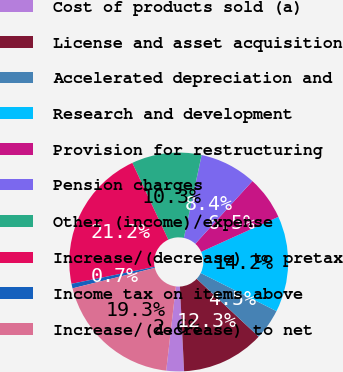Convert chart to OTSL. <chart><loc_0><loc_0><loc_500><loc_500><pie_chart><fcel>Cost of products sold (a)<fcel>License and asset acquisition<fcel>Accelerated depreciation and<fcel>Research and development<fcel>Provision for restructuring<fcel>Pension charges<fcel>Other (income)/expense<fcel>Increase/(decrease) to pretax<fcel>Income tax on items above<fcel>Increase/(decrease) to net<nl><fcel>2.61%<fcel>12.26%<fcel>4.54%<fcel>14.19%<fcel>6.47%<fcel>8.4%<fcel>10.33%<fcel>21.23%<fcel>0.68%<fcel>19.3%<nl></chart> 